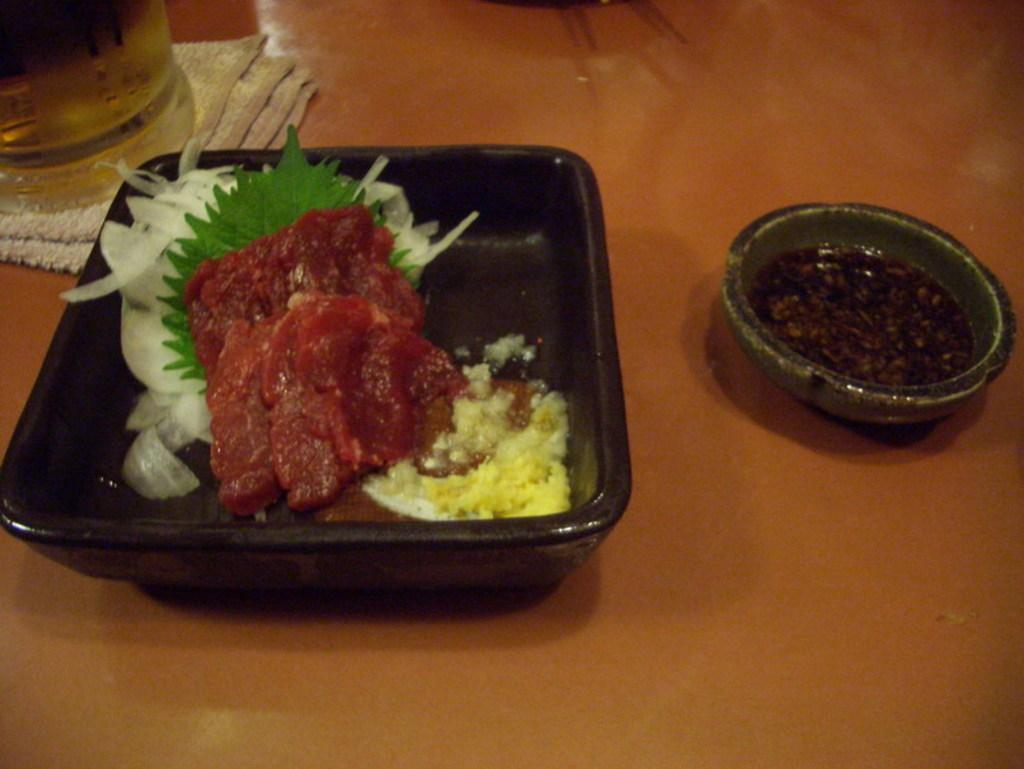What is in the bowl that is visible in the image? There is a bowl with food items in the image. What else can be seen in the image besides the bowl? There is a drink glass in the image. How is the drink glass positioned in the image? The drink glass is placed on a cloth. How many pizzas are being gripped by the person in the image? There is no person present in the image, and therefore no pizzas are being gripped. 